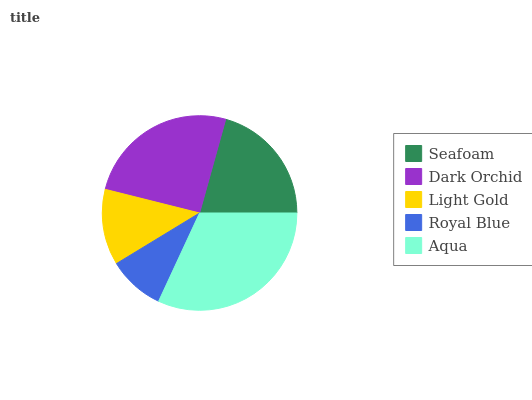Is Royal Blue the minimum?
Answer yes or no. Yes. Is Aqua the maximum?
Answer yes or no. Yes. Is Dark Orchid the minimum?
Answer yes or no. No. Is Dark Orchid the maximum?
Answer yes or no. No. Is Dark Orchid greater than Seafoam?
Answer yes or no. Yes. Is Seafoam less than Dark Orchid?
Answer yes or no. Yes. Is Seafoam greater than Dark Orchid?
Answer yes or no. No. Is Dark Orchid less than Seafoam?
Answer yes or no. No. Is Seafoam the high median?
Answer yes or no. Yes. Is Seafoam the low median?
Answer yes or no. Yes. Is Royal Blue the high median?
Answer yes or no. No. Is Dark Orchid the low median?
Answer yes or no. No. 